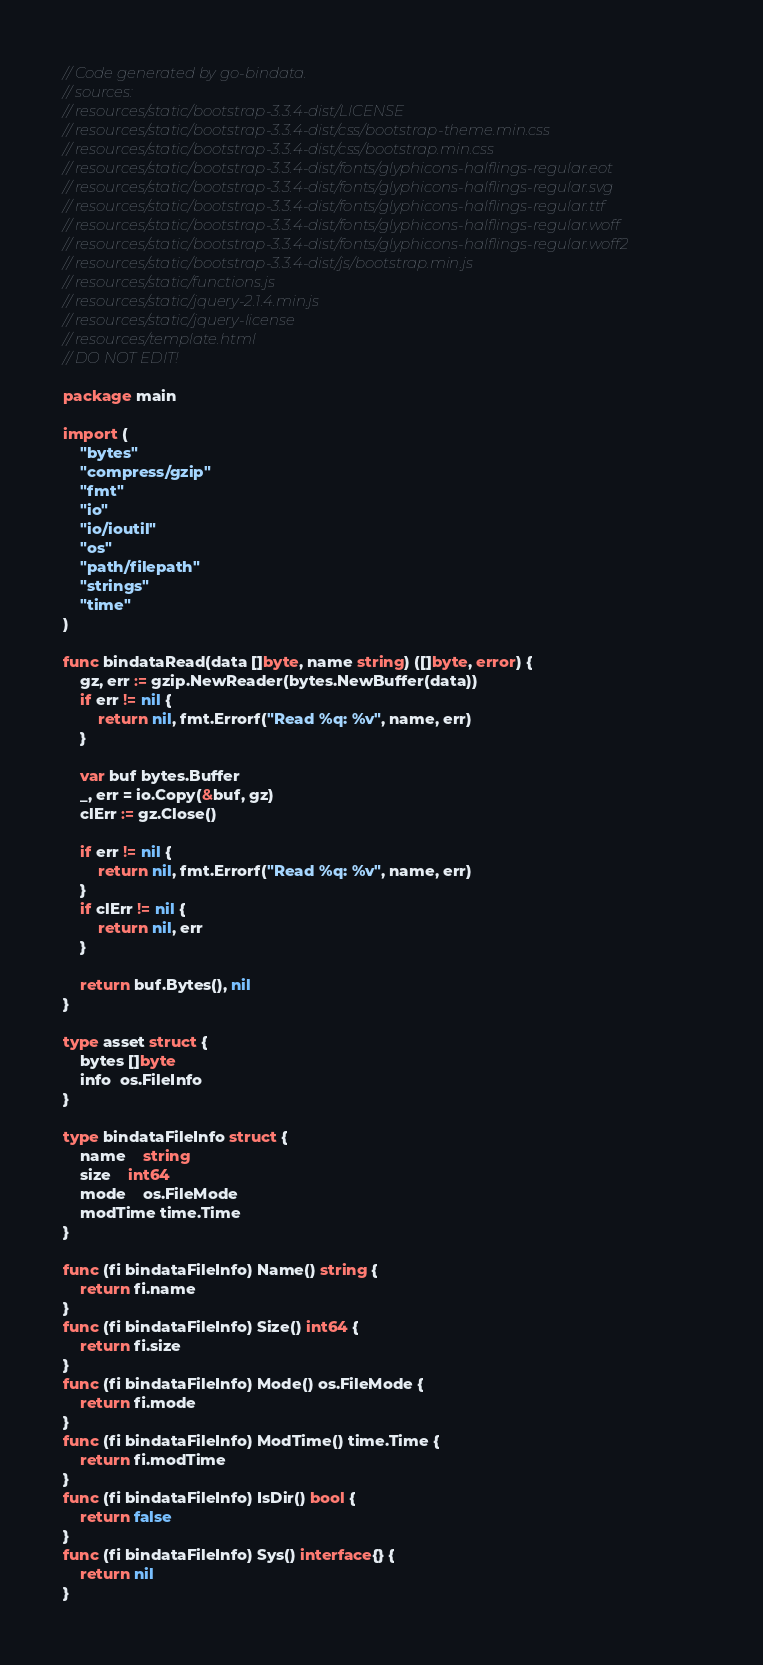Convert code to text. <code><loc_0><loc_0><loc_500><loc_500><_Go_>// Code generated by go-bindata.
// sources:
// resources/static/bootstrap-3.3.4-dist/LICENSE
// resources/static/bootstrap-3.3.4-dist/css/bootstrap-theme.min.css
// resources/static/bootstrap-3.3.4-dist/css/bootstrap.min.css
// resources/static/bootstrap-3.3.4-dist/fonts/glyphicons-halflings-regular.eot
// resources/static/bootstrap-3.3.4-dist/fonts/glyphicons-halflings-regular.svg
// resources/static/bootstrap-3.3.4-dist/fonts/glyphicons-halflings-regular.ttf
// resources/static/bootstrap-3.3.4-dist/fonts/glyphicons-halflings-regular.woff
// resources/static/bootstrap-3.3.4-dist/fonts/glyphicons-halflings-regular.woff2
// resources/static/bootstrap-3.3.4-dist/js/bootstrap.min.js
// resources/static/functions.js
// resources/static/jquery-2.1.4.min.js
// resources/static/jquery-license
// resources/template.html
// DO NOT EDIT!

package main

import (
	"bytes"
	"compress/gzip"
	"fmt"
	"io"
	"io/ioutil"
	"os"
	"path/filepath"
	"strings"
	"time"
)

func bindataRead(data []byte, name string) ([]byte, error) {
	gz, err := gzip.NewReader(bytes.NewBuffer(data))
	if err != nil {
		return nil, fmt.Errorf("Read %q: %v", name, err)
	}

	var buf bytes.Buffer
	_, err = io.Copy(&buf, gz)
	clErr := gz.Close()

	if err != nil {
		return nil, fmt.Errorf("Read %q: %v", name, err)
	}
	if clErr != nil {
		return nil, err
	}

	return buf.Bytes(), nil
}

type asset struct {
	bytes []byte
	info  os.FileInfo
}

type bindataFileInfo struct {
	name    string
	size    int64
	mode    os.FileMode
	modTime time.Time
}

func (fi bindataFileInfo) Name() string {
	return fi.name
}
func (fi bindataFileInfo) Size() int64 {
	return fi.size
}
func (fi bindataFileInfo) Mode() os.FileMode {
	return fi.mode
}
func (fi bindataFileInfo) ModTime() time.Time {
	return fi.modTime
}
func (fi bindataFileInfo) IsDir() bool {
	return false
}
func (fi bindataFileInfo) Sys() interface{} {
	return nil
}
</code> 